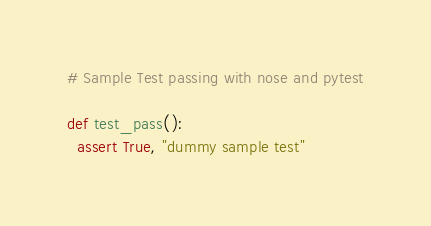<code> <loc_0><loc_0><loc_500><loc_500><_Python_># Sample Test passing with nose and pytest

def test_pass():
  assert True, "dummy sample test"
</code> 